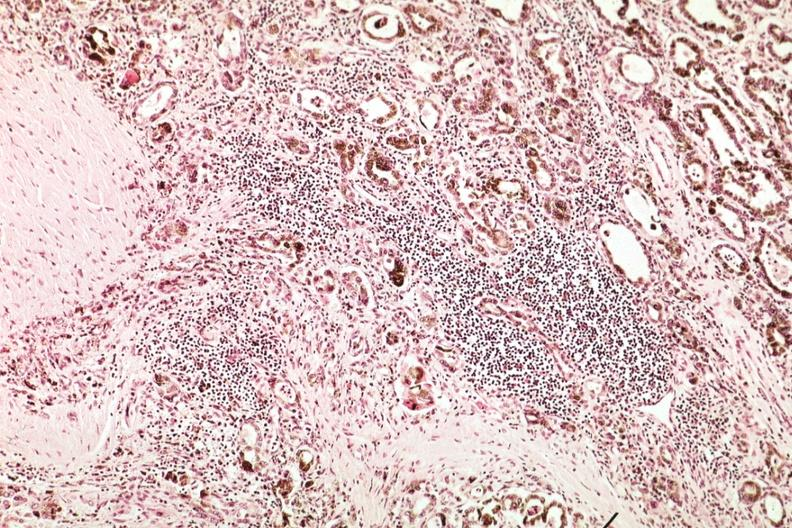what does this image show?
Answer the question using a single word or phrase. Marked atrophy with iron in epithelium and lymphocytic infiltrate 